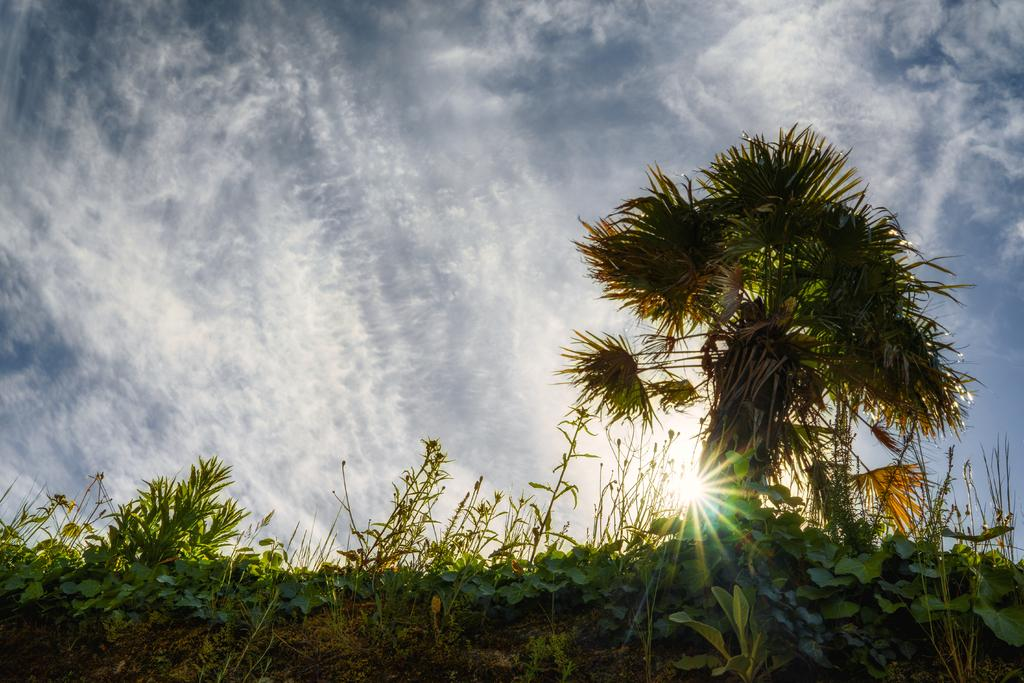What type of vegetation is on the right side of the image? There is a tree on the right side of the image. What can be seen in the sky in the image? There are clouds visible in the sky in the image. What type of copper material is present in the image? There is no copper material present in the image. What level of order can be observed in the image? The image does not depict a specific level of order; it simply shows a tree and clouds in the sky. 